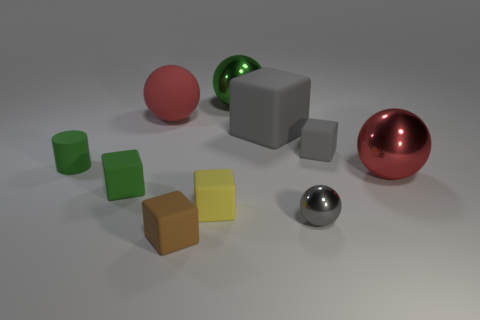Subtract all brown blocks. How many blocks are left? 4 Subtract all small brown cubes. How many cubes are left? 4 Subtract all red cubes. Subtract all gray balls. How many cubes are left? 5 Subtract all spheres. How many objects are left? 6 Add 1 brown blocks. How many brown blocks are left? 2 Add 5 big purple rubber cylinders. How many big purple rubber cylinders exist? 5 Subtract 0 brown balls. How many objects are left? 10 Subtract all green rubber balls. Subtract all big rubber balls. How many objects are left? 9 